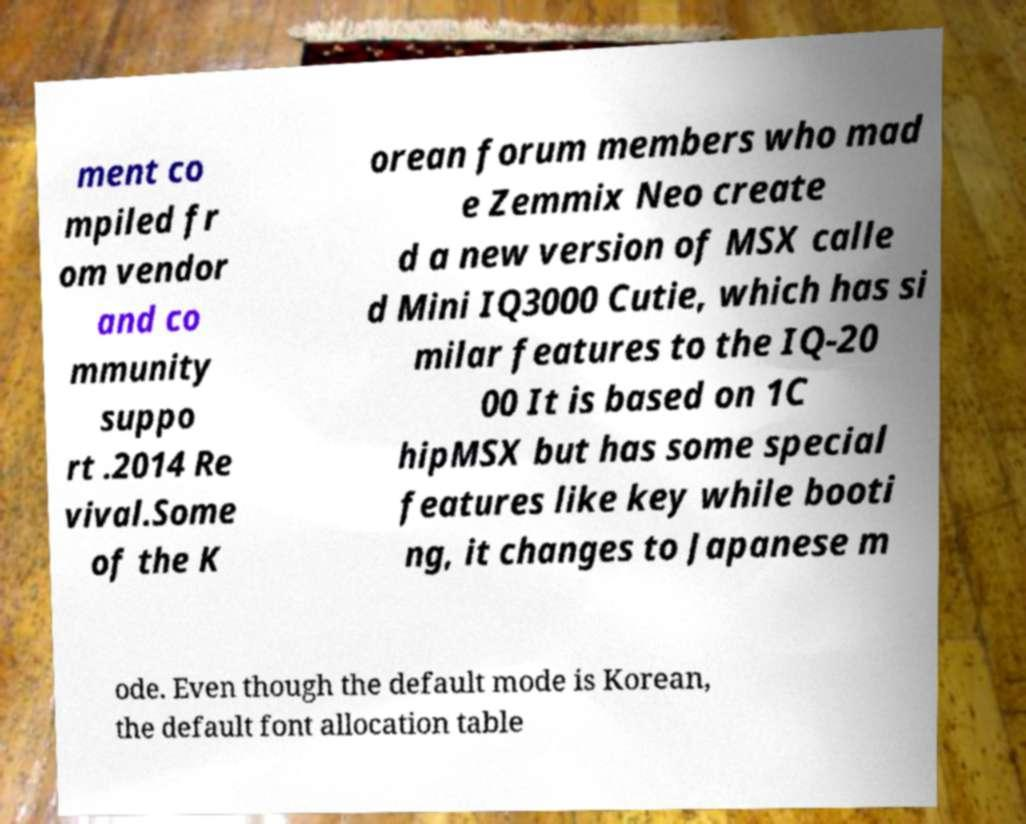What messages or text are displayed in this image? I need them in a readable, typed format. ment co mpiled fr om vendor and co mmunity suppo rt .2014 Re vival.Some of the K orean forum members who mad e Zemmix Neo create d a new version of MSX calle d Mini IQ3000 Cutie, which has si milar features to the IQ-20 00 It is based on 1C hipMSX but has some special features like key while booti ng, it changes to Japanese m ode. Even though the default mode is Korean, the default font allocation table 